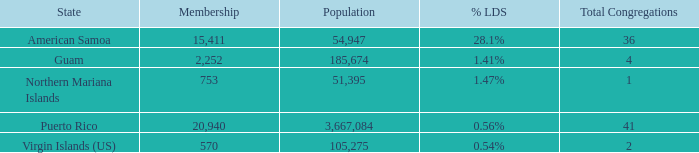How many congregations are there in total when the lds proportion is 0.54% and the population is more than 105,275? 0.0. 